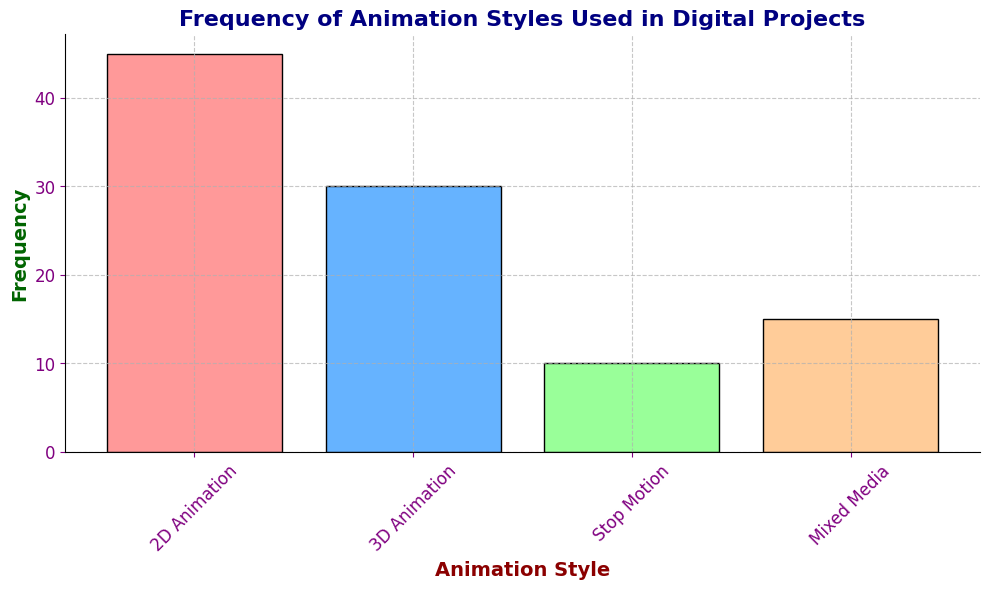What is the most frequently used animation style? The height of the bar for 2D Animation is the tallest among all four bars, representing the highest frequency.
Answer: 2D Animation Which animation style has the lowest frequency? The bar corresponding to Stop Motion is the shortest, indicating it has the lowest frequency.
Answer: Stop Motion How many more times is 2D Animation used compared to Stop Motion? The frequency of 2D Animation is 45 and for Stop Motion is 10. The difference is 45 - 10 = 35.
Answer: 35 What's the total frequency of all animation styles combined? Sum the frequencies of all styles: 45 (2D) + 30 (3D) + 10 (Stop Motion) + 15 (Mixed Media) = 100.
Answer: 100 What is the difference in frequency between Mixed Media and 3D Animation? The frequency of Mixed Media is 15 and 3D Animation is 30. The difference is 30 - 15 = 15.
Answer: 15 Is the frequency of 3D Animation greater than twice the frequency of Mixed Media? Twice the frequency of Mixed Media would be 15 * 2 = 30. The frequency of 3D Animation is 30, which is equal to but not greater than twice the frequency of Mixed Media.
Answer: No What fraction of the total animation styles does 2D Animation represent? The frequency of 2D Animation is 45, and the total is 100. The fraction is 45/100 = 0.45.
Answer: 0.45 Which two animation styles combined have a frequency of 40? Adding the frequencies: 2D (45) + 3D (30) = 75, 2D (45) + Stop Motion (10) = 55, 2D (45) + Mixed Media (15) = 60, 3D (30) + Stop Motion (10) = 40.
Answer: 3D Animation and Stop Motion Is the frequency of 2D Animation greater than the combined frequency of 3D Animation and Mixed Media? The combined frequency of 3D Animation and Mixed Media is 30 + 15 = 45. The frequency of 2D Animation is also 45. Since they are equal, not greater.
Answer: No 